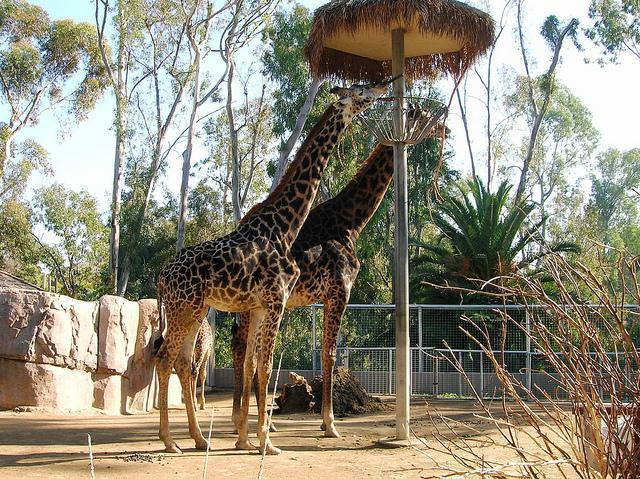How many giraffes are here?
Give a very brief answer. 2. How many giraffe are walking by the wall?
Give a very brief answer. 2. How many giraffes are in the picture?
Give a very brief answer. 2. 